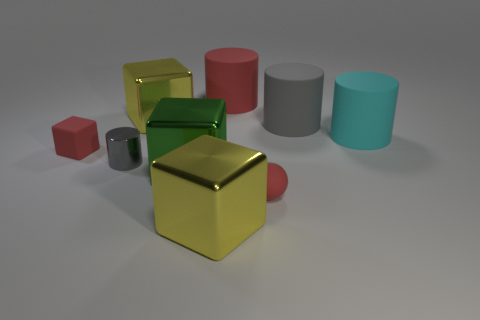What colors are the objects in the image? The objects in the image come in various colors such as red, gold, green, gray, and a shade of cyan. Is there any significance to the arrangement of the objects? The arrangement appears to be random with no discernible pattern, creating a visually balanced composition that draws the eye to the different shapes and colors. 